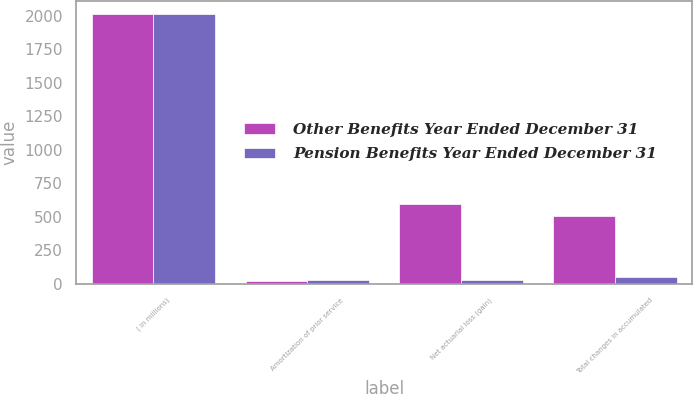<chart> <loc_0><loc_0><loc_500><loc_500><stacked_bar_chart><ecel><fcel>( in millions)<fcel>Amortization of prior service<fcel>Net actuarial loss (gain)<fcel>Total changes in accumulated<nl><fcel>Other Benefits Year Ended December 31<fcel>2014<fcel>19<fcel>599<fcel>508<nl><fcel>Pension Benefits Year Ended December 31<fcel>2014<fcel>26<fcel>24<fcel>50<nl></chart> 